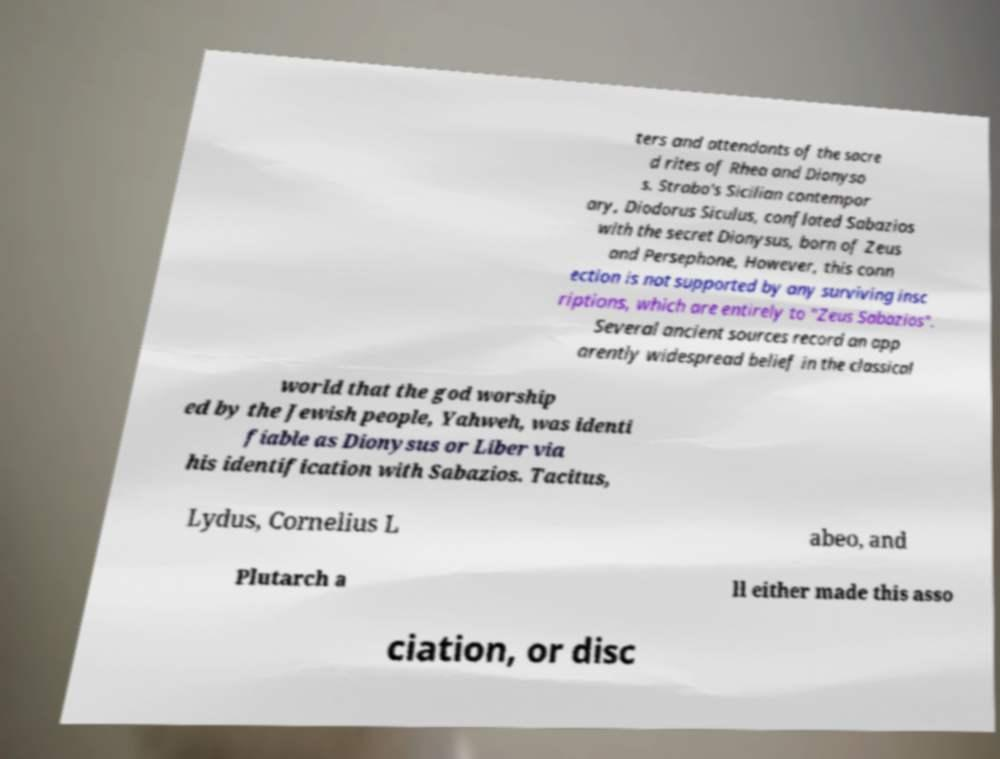Please identify and transcribe the text found in this image. ters and attendants of the sacre d rites of Rhea and Dionyso s. Strabo's Sicilian contempor ary, Diodorus Siculus, conflated Sabazios with the secret Dionysus, born of Zeus and Persephone, However, this conn ection is not supported by any surviving insc riptions, which are entirely to "Zeus Sabazios". Several ancient sources record an app arently widespread belief in the classical world that the god worship ed by the Jewish people, Yahweh, was identi fiable as Dionysus or Liber via his identification with Sabazios. Tacitus, Lydus, Cornelius L abeo, and Plutarch a ll either made this asso ciation, or disc 